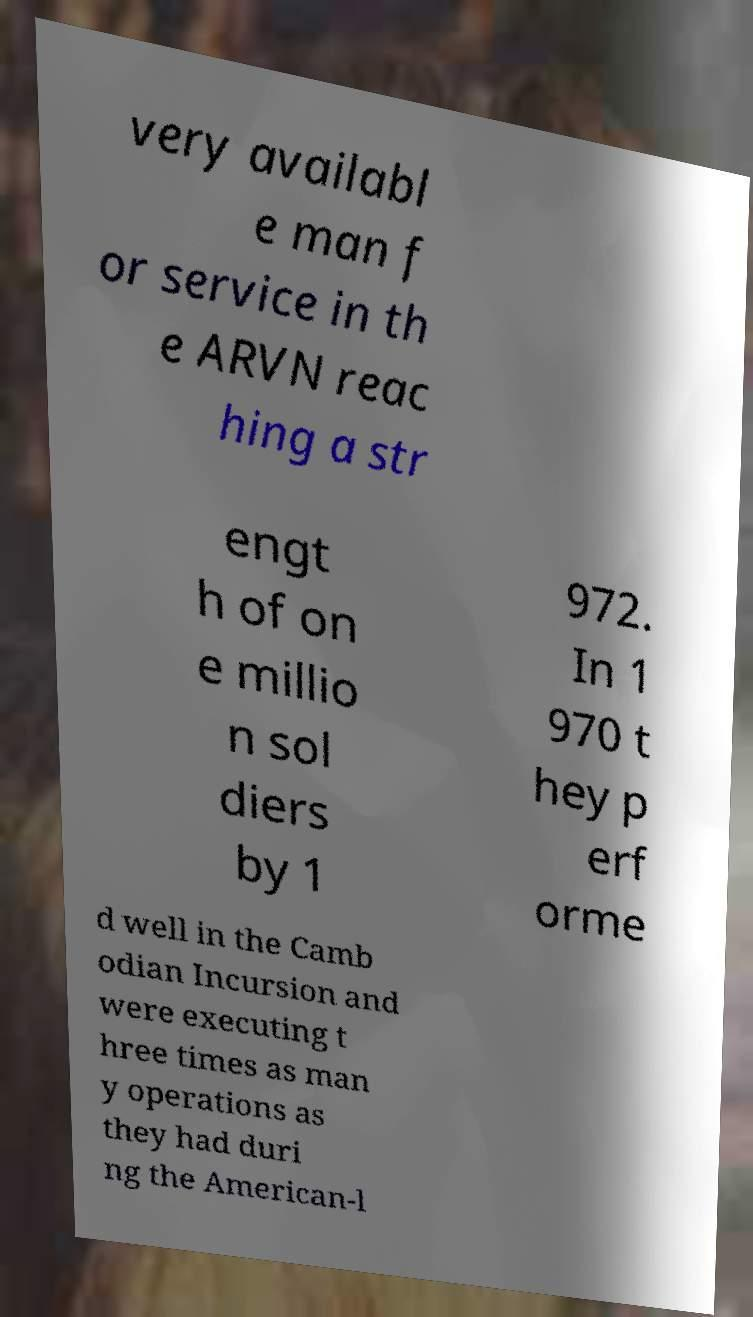Please read and relay the text visible in this image. What does it say? very availabl e man f or service in th e ARVN reac hing a str engt h of on e millio n sol diers by 1 972. In 1 970 t hey p erf orme d well in the Camb odian Incursion and were executing t hree times as man y operations as they had duri ng the American-l 